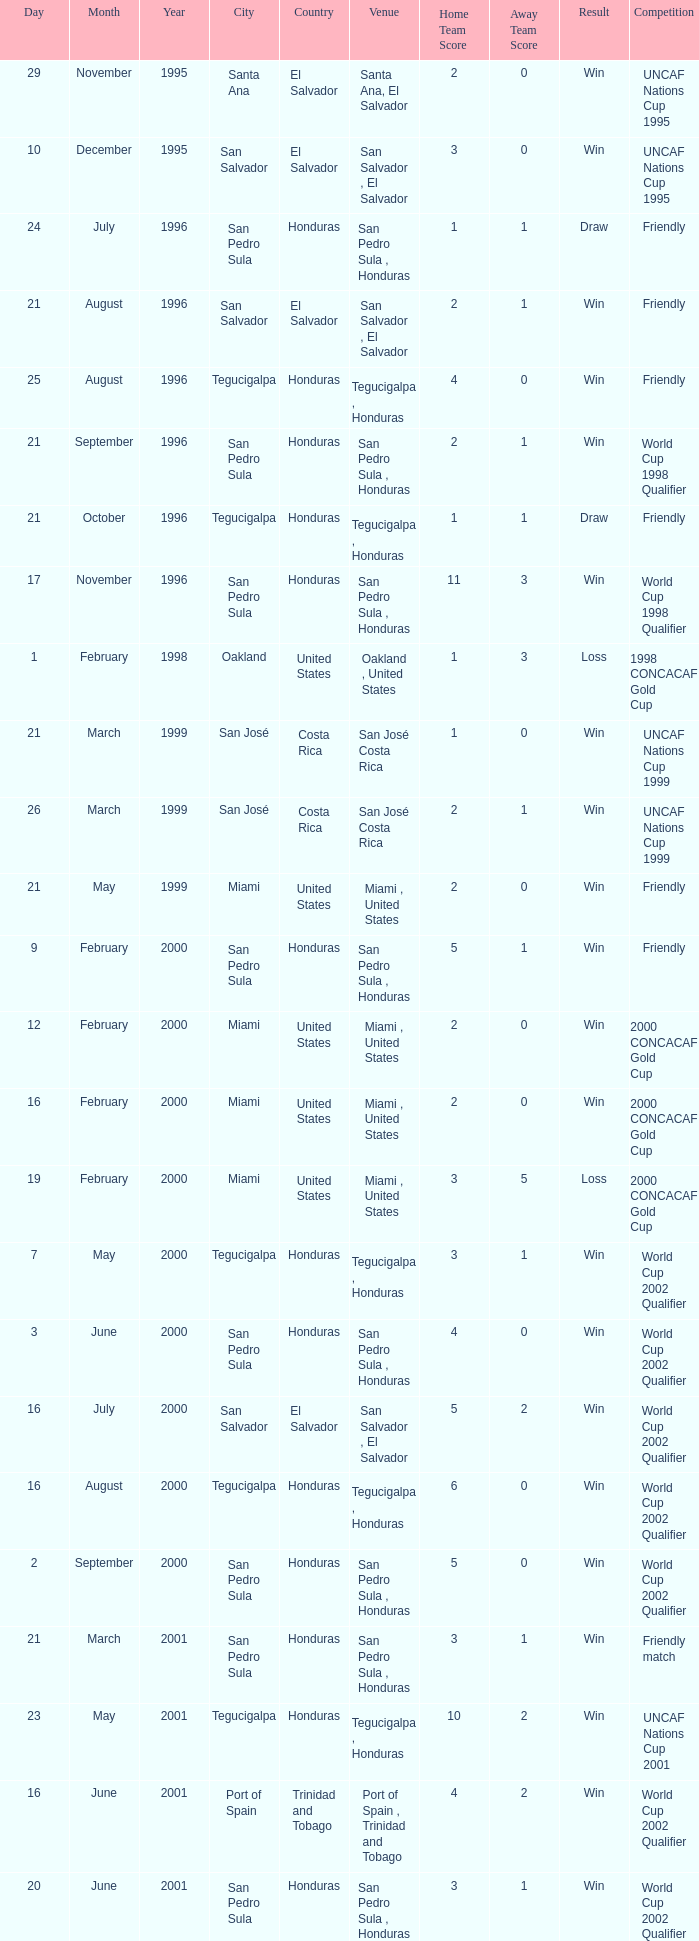Would you be able to parse every entry in this table? {'header': ['Day', 'Month', 'Year', 'City', 'Country', 'Venue', 'Home Team Score', 'Away Team Score', 'Result', 'Competition'], 'rows': [['29', 'November', '1995', 'Santa Ana', 'El Salvador', 'Santa Ana, El Salvador', '2', '0', 'Win', 'UNCAF Nations Cup 1995'], ['10', 'December', '1995', 'San Salvador', 'El Salvador', 'San Salvador , El Salvador', '3', '0', 'Win', 'UNCAF Nations Cup 1995'], ['24', 'July', '1996', 'San Pedro Sula', 'Honduras', 'San Pedro Sula , Honduras', '1', '1', 'Draw', 'Friendly'], ['21', 'August', '1996', 'San Salvador', 'El Salvador', 'San Salvador , El Salvador', '2', '1', 'Win', 'Friendly'], ['25', 'August', '1996', 'Tegucigalpa', 'Honduras', 'Tegucigalpa , Honduras', '4', '0', 'Win', 'Friendly'], ['21', 'September', '1996', 'San Pedro Sula', 'Honduras', 'San Pedro Sula , Honduras', '2', '1', 'Win', 'World Cup 1998 Qualifier'], ['21', 'October', '1996', 'Tegucigalpa', 'Honduras', 'Tegucigalpa , Honduras', '1', '1', 'Draw', 'Friendly'], ['17', 'November', '1996', 'San Pedro Sula', 'Honduras', 'San Pedro Sula , Honduras', '11', '3', 'Win', 'World Cup 1998 Qualifier'], ['1', 'February', '1998', 'Oakland', 'United States', 'Oakland , United States', '1', '3', 'Loss', '1998 CONCACAF Gold Cup'], ['21', 'March', '1999', 'San José', 'Costa Rica', 'San José Costa Rica', '1', '0', 'Win', 'UNCAF Nations Cup 1999'], ['26', 'March', '1999', 'San José', 'Costa Rica', 'San José Costa Rica', '2', '1', 'Win', 'UNCAF Nations Cup 1999'], ['21', 'May', '1999', 'Miami', 'United States', 'Miami , United States', '2', '0', 'Win', 'Friendly'], ['9', 'February', '2000', 'San Pedro Sula', 'Honduras', 'San Pedro Sula , Honduras', '5', '1', 'Win', 'Friendly'], ['12', 'February', '2000', 'Miami', 'United States', 'Miami , United States', '2', '0', 'Win', '2000 CONCACAF Gold Cup'], ['16', 'February', '2000', 'Miami', 'United States', 'Miami , United States', '2', '0', 'Win', '2000 CONCACAF Gold Cup'], ['19', 'February', '2000', 'Miami', 'United States', 'Miami , United States', '3', '5', 'Loss', '2000 CONCACAF Gold Cup'], ['7', 'May', '2000', 'Tegucigalpa', 'Honduras', 'Tegucigalpa , Honduras', '3', '1', 'Win', 'World Cup 2002 Qualifier'], ['3', 'June', '2000', 'San Pedro Sula', 'Honduras', 'San Pedro Sula , Honduras', '4', '0', 'Win', 'World Cup 2002 Qualifier'], ['16', 'July', '2000', 'San Salvador', 'El Salvador', 'San Salvador , El Salvador', '5', '2', 'Win', 'World Cup 2002 Qualifier'], ['16', 'August', '2000', 'Tegucigalpa', 'Honduras', 'Tegucigalpa , Honduras', '6', '0', 'Win', 'World Cup 2002 Qualifier'], ['2', 'September', '2000', 'San Pedro Sula', 'Honduras', 'San Pedro Sula , Honduras', '5', '0', 'Win', 'World Cup 2002 Qualifier'], ['21', 'March', '2001', 'San Pedro Sula', 'Honduras', 'San Pedro Sula , Honduras', '3', '1', 'Win', 'Friendly match'], ['23', 'May', '2001', 'Tegucigalpa', 'Honduras', 'Tegucigalpa , Honduras', '10', '2', 'Win', 'UNCAF Nations Cup 2001'], ['16', 'June', '2001', 'Port of Spain', 'Trinidad and Tobago', 'Port of Spain , Trinidad and Tobago', '4', '2', 'Win', 'World Cup 2002 Qualifier'], ['20', 'June', '2001', 'San Pedro Sula', 'Honduras', 'San Pedro Sula , Honduras', '3', '1', 'Win', 'World Cup 2002 Qualifier'], ['1', 'September', '2001', 'Washington, D.C.', 'United States', 'Washington, D.C. , United States', '2', '1', 'Win', 'World Cup 2002 Qualifier'], ['2', 'May', '2002', 'Kobe', 'Japan', 'Kobe , Japan', '3', '3', 'Draw', 'Carlsberg Cup'], ['28', 'April', '2004', 'Fort Lauderdale', 'United States', 'Fort Lauderdale , United States', '1', '1', 'Draw', 'Friendly'], ['19', 'June', '2004', 'San Pedro Sula', 'Honduras', 'San Pedro Sula , Honduras', '4', '0', 'Win', 'World Cup 2006 Qualification'], ['19', 'April', '2007', 'La Ceiba', 'Honduras', 'La Ceiba , Honduras', '1', '3', 'Loss', 'Friendly'], ['25', 'May', '2007', 'Mérida', 'Venezuela', 'Mérida , Venezuela', '1', '2', 'Loss', 'Friendly'], ['13', 'June', '2007', 'Houston', 'United States', 'Houston , United States', '5', '0', 'Win', '2007 CONCACAF Gold Cup'], ['17', 'June', '2007', 'Houston', 'United States', 'Houston , United States', '1', '2', 'Loss', '2007 CONCACAF Gold Cup'], ['18', 'January', '2009', 'Miami', 'United States', 'Miami , United States', '2', '0', 'Win', 'Friendly'], ['26', 'January', '2009', 'Tegucigalpa', 'Honduras', 'Tegucigalpa , Honduras', '2', '0', 'Win', 'UNCAF Nations Cup 2009'], ['28', 'March', '2009', 'Port of Spain', 'Trinidad and Tobago', 'Port of Spain , Trinidad and Tobago', '1', '1', 'Draw', 'World Cup 2010 Qualification'], ['1', 'April', '2009', 'San Pedro Sula', 'Honduras', 'San Pedro Sula , Honduras', '3', '1', 'Win', 'World Cup 2010 Qualification'], ['10', 'June', '2009', 'San Pedro Sula', 'Honduras', 'San Pedro Sula , Honduras', '1', '0', 'Win', 'World Cup 2010 Qualification'], ['12', 'August', '2009', 'San Pedro Sula', 'Honduras', 'San Pedro Sula , Honduras', '4', '0', 'Win', 'World Cup 2010 Qualification'], ['5', 'September', '2009', 'San Pedro Sula', 'Honduras', 'San Pedro Sula , Honduras', '4', '1', 'Win', 'World Cup 2010 Qualification'], ['14', 'October', '2009', 'San Salvador', 'El Salvador', 'San Salvador , El Salvador', '1', '0', 'Win', 'World Cup 2010 Qualification'], ['23', 'January', '2010', 'Carson', 'United States', 'Carson , United States', '3', '1', 'Win', 'Friendly']]} What is the venue for the friendly competition and score of 4-0? Tegucigalpa , Honduras. 